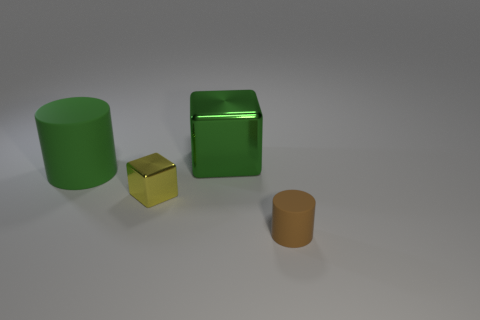Add 4 gray cylinders. How many objects exist? 8 Subtract all red matte balls. Subtract all brown matte things. How many objects are left? 3 Add 2 cubes. How many cubes are left? 4 Add 1 tiny yellow metallic cubes. How many tiny yellow metallic cubes exist? 2 Subtract 0 blue cylinders. How many objects are left? 4 